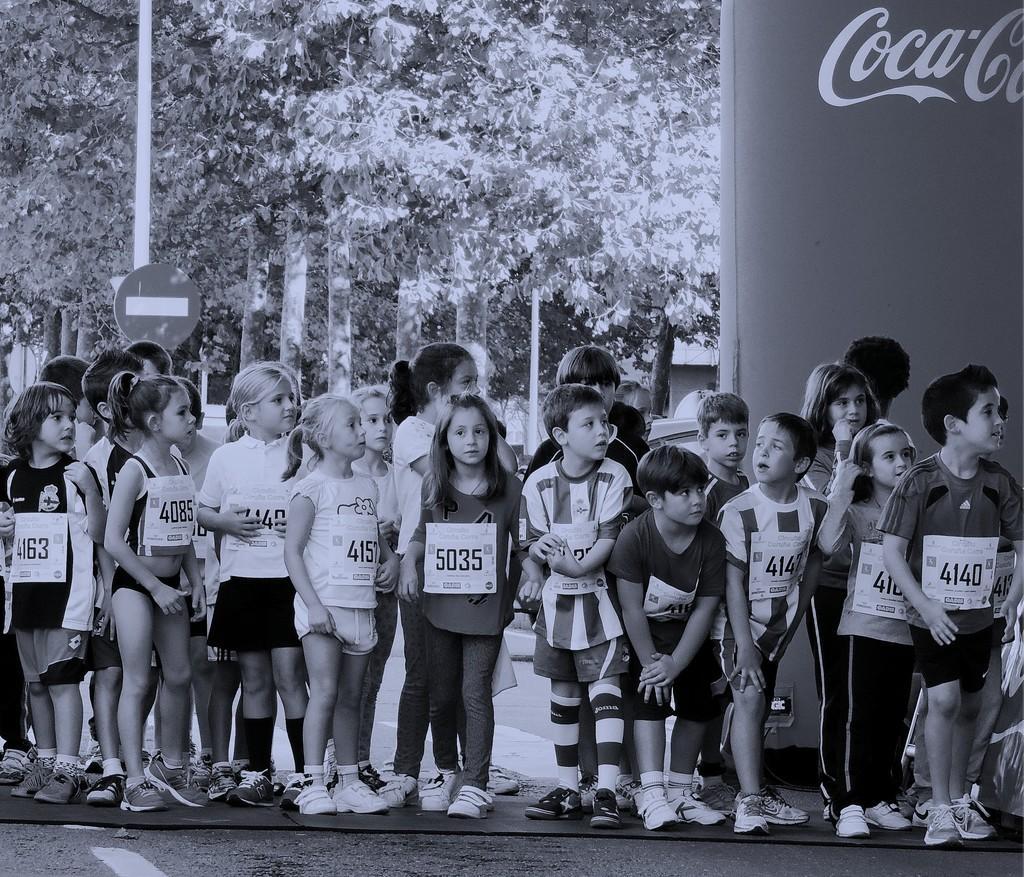How would you summarize this image in a sentence or two? In this image there are children standing, in the background there are trees. 